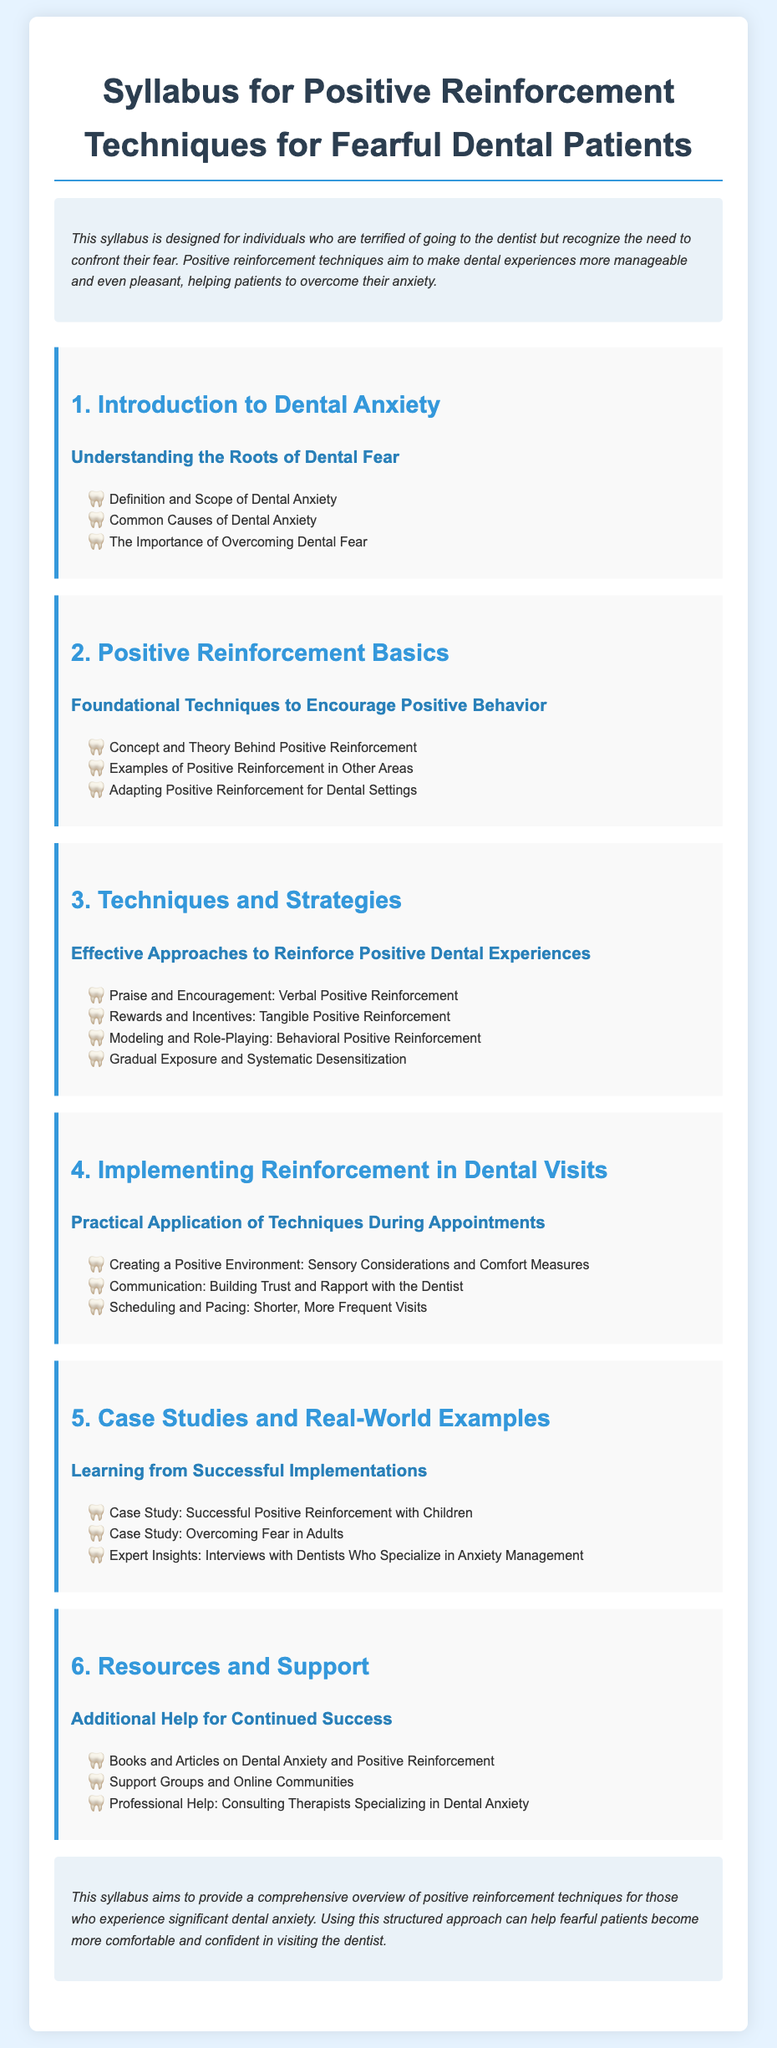What is the title of the syllabus? The title is explicitly stated at the top of the document, which is about reinforcement techniques for dental anxiety.
Answer: Syllabus for Positive Reinforcement Techniques for Fearful Dental Patients What is one common cause of dental anxiety mentioned? The document lists specific causes under the "Common Causes of Dental Anxiety" section.
Answer: Common Causes of Dental Anxiety What type of reinforcement focuses on verbal encouragement? The syllabus categorizes techniques, including types that emphasize specific forms of reinforcement.
Answer: Verbal Positive Reinforcement What is one practical application technique suggested for dental visits? The document describes methods to create a positive experience during dental appointments under specific sections.
Answer: Creating a Positive Environment How many case studies are mentioned in the syllabus? The section on case studies includes multiple examples of successful implementations, so the number can be directly identified.
Answer: Three Which professional help is recommended for dental anxiety? The document lists a type of professional who specializes in the area of dental anxiety management.
Answer: Therapists Specializing in Dental Anxiety What foundational concept is discussed in the second section? The syllabus outlines basic principles surrounding reinforcement techniques in the second section dedicated to it.
Answer: Positive Reinforcement What is a technique for gradual exposure mentioned in the syllabus? The syllabus provides a specific strategy for addressing fear in the section about techniques and strategies.
Answer: Systematic Desensitization 